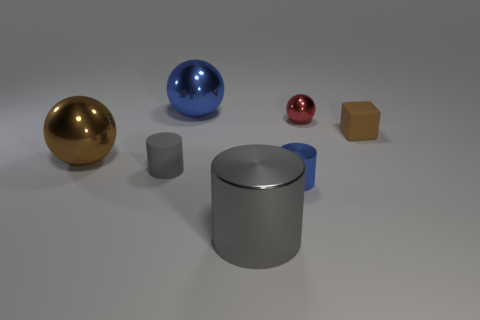There is a small cylinder that is the same color as the big cylinder; what is its material?
Ensure brevity in your answer.  Rubber. Are there any other gray things of the same shape as the big gray object?
Make the answer very short. Yes. What number of tiny blue objects have the same shape as the red thing?
Your response must be concise. 0. Does the large cylinder have the same color as the matte block?
Your answer should be compact. No. Are there fewer brown metallic things than blue matte cylinders?
Ensure brevity in your answer.  No. What is the material of the thing that is behind the tiny red shiny object?
Keep it short and to the point. Metal. There is a gray cylinder that is the same size as the blue cylinder; what material is it?
Provide a short and direct response. Rubber. What material is the cylinder that is to the right of the big thing that is in front of the metallic sphere in front of the brown rubber block?
Make the answer very short. Metal. Does the object to the right of the red object have the same size as the large shiny cylinder?
Your answer should be very brief. No. Is the number of tiny blue metal objects greater than the number of large cyan metallic blocks?
Provide a short and direct response. Yes. 